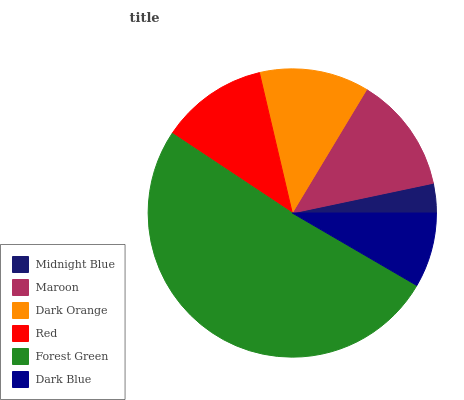Is Midnight Blue the minimum?
Answer yes or no. Yes. Is Forest Green the maximum?
Answer yes or no. Yes. Is Maroon the minimum?
Answer yes or no. No. Is Maroon the maximum?
Answer yes or no. No. Is Maroon greater than Midnight Blue?
Answer yes or no. Yes. Is Midnight Blue less than Maroon?
Answer yes or no. Yes. Is Midnight Blue greater than Maroon?
Answer yes or no. No. Is Maroon less than Midnight Blue?
Answer yes or no. No. Is Dark Orange the high median?
Answer yes or no. Yes. Is Red the low median?
Answer yes or no. Yes. Is Red the high median?
Answer yes or no. No. Is Midnight Blue the low median?
Answer yes or no. No. 